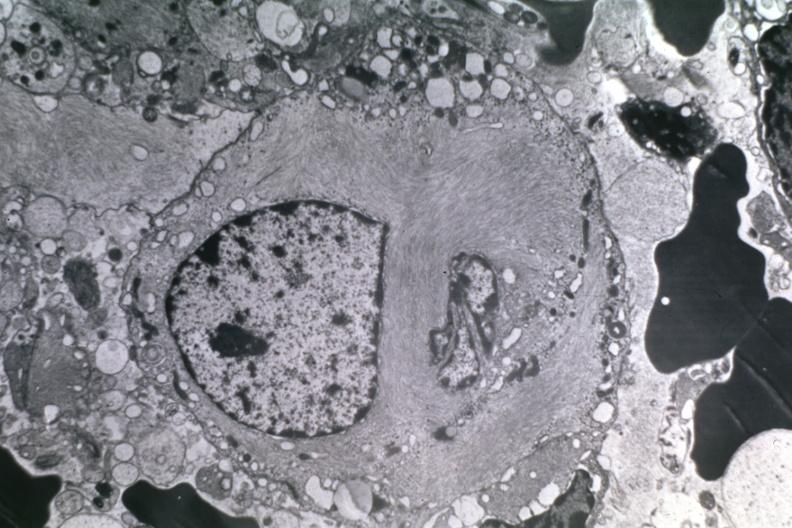s metastatic carcinoma lung present?
Answer the question using a single word or phrase. No 